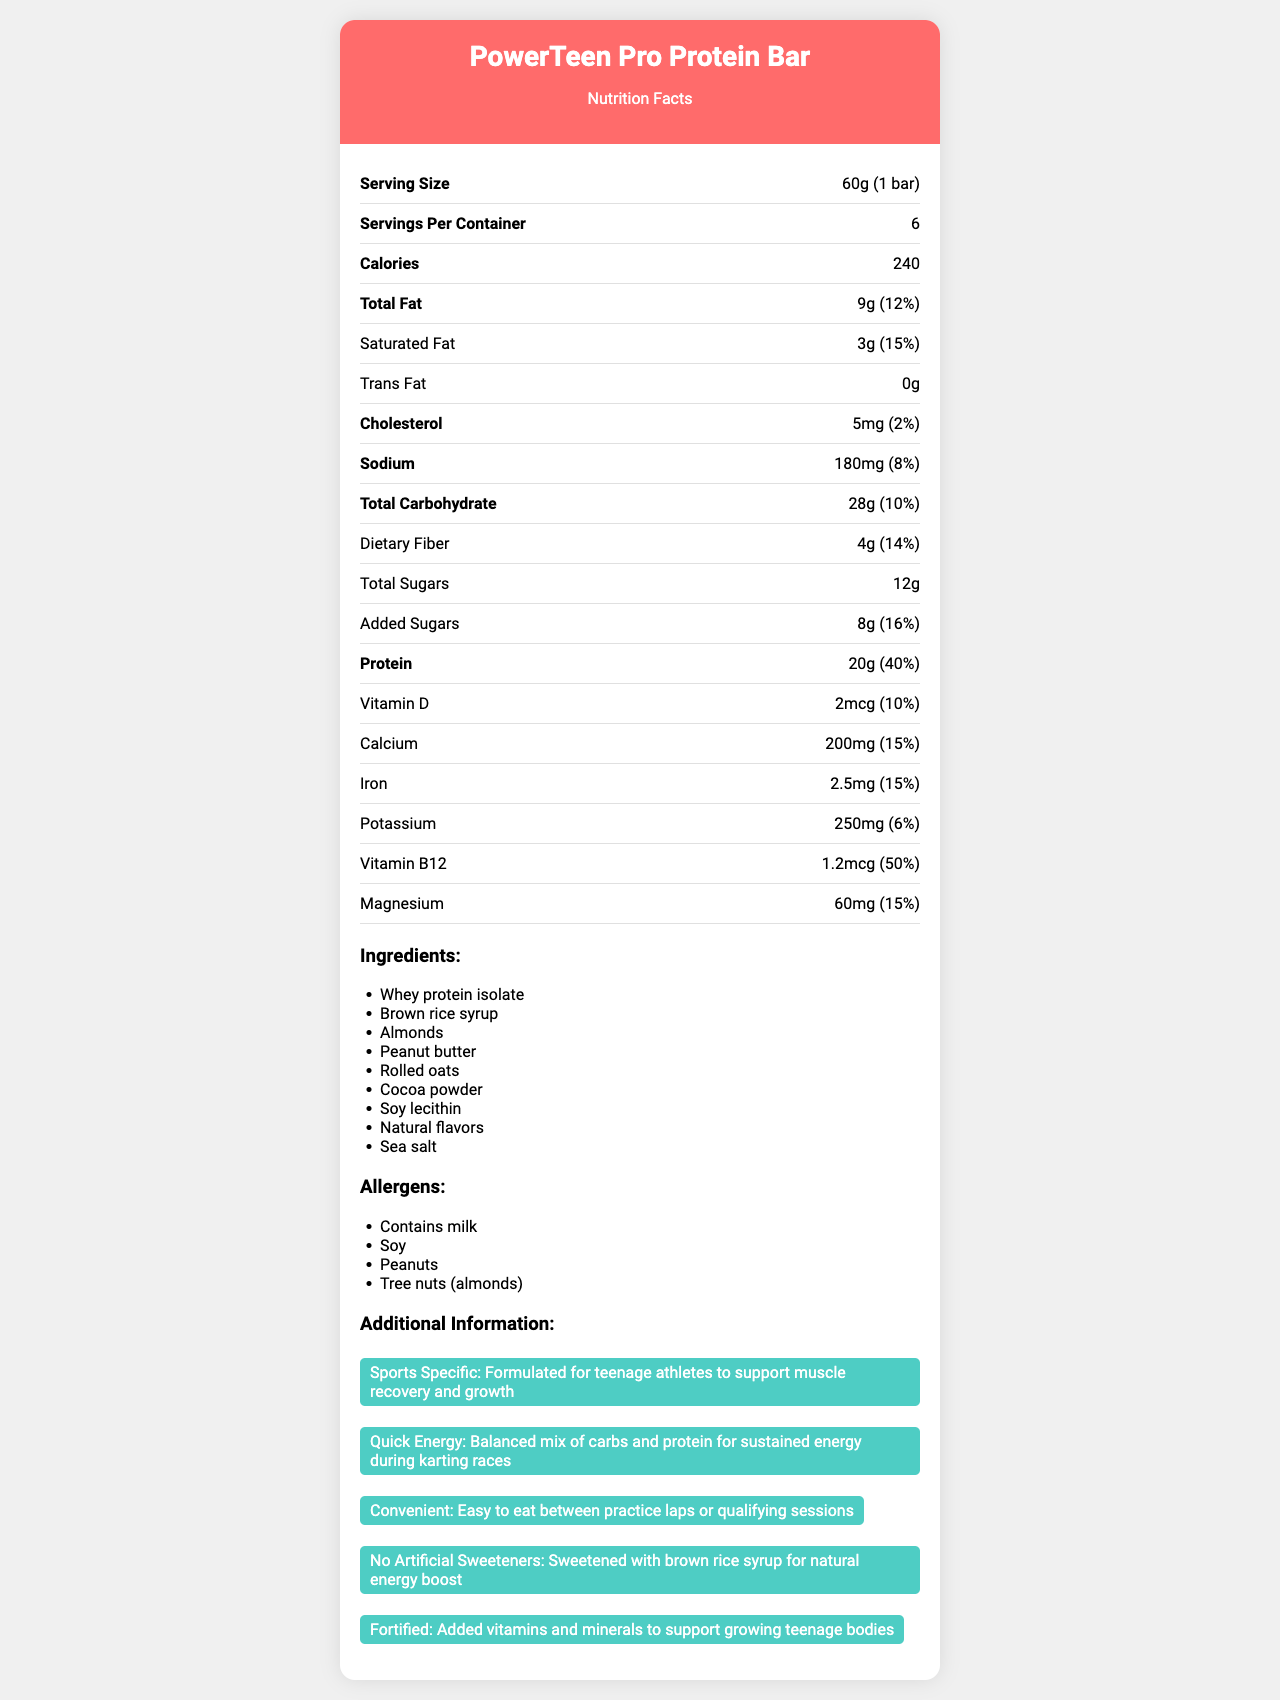what is the serving size of the PowerTeen Pro Protein Bar? The document states that the serving size for the PowerTeen Pro Protein Bar is 60g, which equates to 1 bar.
Answer: 60g (1 bar) how many calories are in one serving of this protein bar? The document lists the calories per serving as 240.
Answer: 240 calories what is the total fat content in a single serving? As per the document, the total fat content per serving is 9 grams.
Answer: 9g how many grams of protein does one PowerTeen Pro Protein Bar contain? The document specifies that there are 20 grams of protein per serving.
Answer: 20g what is the daily value percentage of calcium provided by one bar? The document indicates that one bar provides 15% of the daily value for calcium.
Answer: 15% which ingredient is listed first in the ingredients list? A. Brown rice syrup B. Soy lecithin C. Whey protein isolate D. Sea salt The document lists Whey protein isolate as the first ingredient, which is typically the primary ingredient by weight.
Answer: C. Whey protein isolate what is the daily value percentage of saturated fat in one serving of this protein bar? A. 10% B. 15% C. 8% D. 5% According to the document, the daily value percentage for saturated fat per serving is 15%.
Answer: B. 15% are there any artificial sweeteners in the PowerTeen Pro Protein Bar? The document mentions that the product contains no artificial sweeteners and is sweetened with brown rice syrup for a natural energy boost.
Answer: No does the product contain any tree nuts besides almonds? The allergen section states the product contains almonds but does not mention any other tree nuts.
Answer: No is the protein bar formulated specifically for adult athletes? The additional information section specifies that the bar is formulated for teenage athletes.
Answer: No summarize the main nutritional benefits of the PowerTeen Pro Protein Bar. The document details that the protein bar is engineered for teenage athletes' nutritional needs, helping in muscle recovery, and energy maintenance, and is enriched with crucial vitamins and minerals conducive to their growth.
Answer: The PowerTeen Pro Protein Bar is designed to support teenage athletes with 20g of protein, 240 calories, and various essential vitamins and minerals. It contains a balanced mix of carbs and protein to provide sustained energy and muscle recovery. Additionally, it is fortified with vitamins and minerals, including Vitamin D, Calcium, Iron, and Vitamin B12. what are the vitamins included in the PowerTeen Pro protein bar's nutritional breakdown? The document lists Vitamin D and Vitamin B12 as the vitamins included in the protein bar, along with their respective amounts and daily values.
Answer: Vitamin D, Vitamin B12 how much trans fat does each protein bar contain? The document explicitly states that the content of trans fat in each protein bar is 0 grams.
Answer: 0g what is the sodium content per serving, and what percentage of the daily value does it represent? The document states that each serving contains 180mg of sodium, which equates to 8% of the daily value.
Answer: 180mg, 8% how many servings are there per container? According to the document, there are 6 servings per container.
Answer: 6 how are the flavors of the PowerTeen Pro Protein Bar described? The ingredients section lists "Natural flavors" among the components, indicating the type of flavors used in the bar.
Answer: Natural flavors what is the total carbohydrate content, and how much of this is dietary fiber? The document indicates 28 grams of total carbohydrate content per serving, of which 4 grams are dietary fiber.
Answer: 28g total carbohydrates, 4g dietary fiber what are the potential allergens in this protein bar? The allergen section lists milk, soy, peanuts, and tree nuts (specifically almonds) as potential allergens.
Answer: Milk, Soy, Peanuts, Tree nuts (almonds) what is the potassium content per serving, and what is its daily value percentage? The document specifies that each serving contains 250mg of potassium, providing 6% of the daily value.
Answer: 250mg, 6% does the document provide the expiration date of the protein bar? The document does not mention any expiration date for the protein bar.
Answer: Cannot be determined 